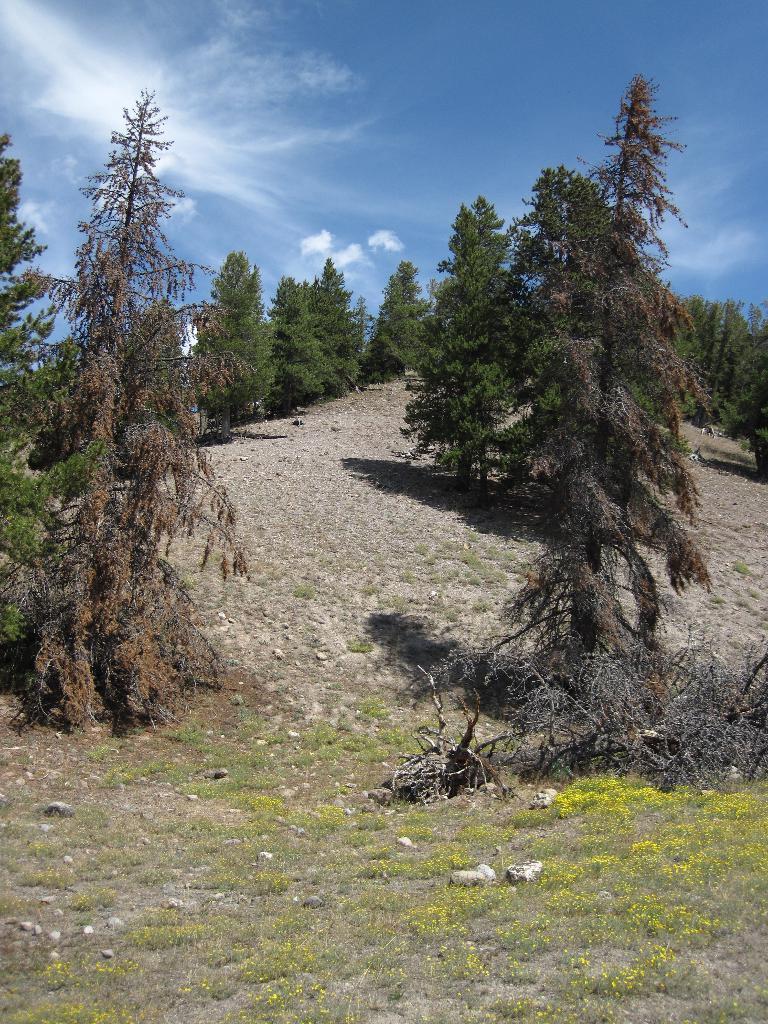How would you summarize this image in a sentence or two? In this picture we can observe some trees and grass on the ground. There are some small stones and sand. In the background there is a sky and clouds. 